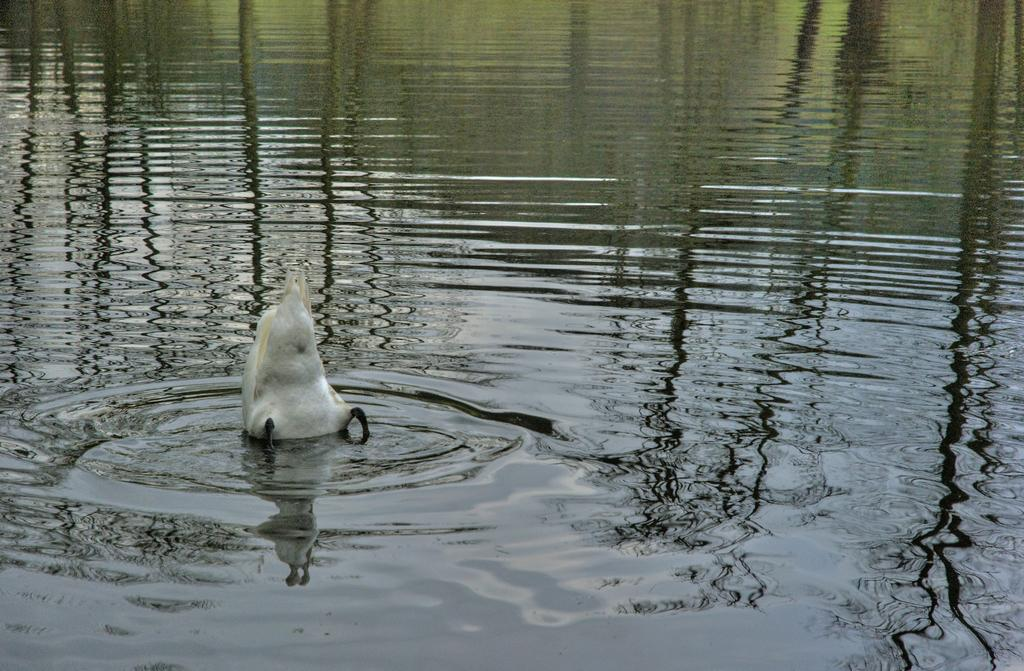What is visible in the image? Water is visible in the image. Can you describe the animal in the water? There is a white-colored animal in the water on the left side. What scientific experiment is being conducted with the cart in the image? There is no cart present in the image, and therefore no scientific experiment can be observed. 